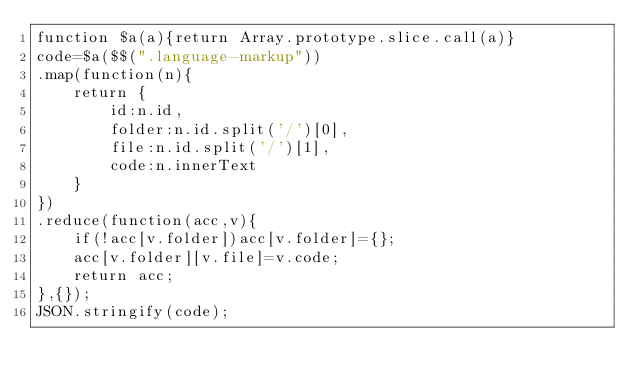<code> <loc_0><loc_0><loc_500><loc_500><_JavaScript_>function $a(a){return Array.prototype.slice.call(a)}
code=$a($$(".language-markup"))
.map(function(n){
	return {
		id:n.id,
		folder:n.id.split('/')[0],
		file:n.id.split('/')[1],
		code:n.innerText
	}
})
.reduce(function(acc,v){
	if(!acc[v.folder])acc[v.folder]={};
	acc[v.folder][v.file]=v.code;
	return acc;
},{});
JSON.stringify(code);</code> 